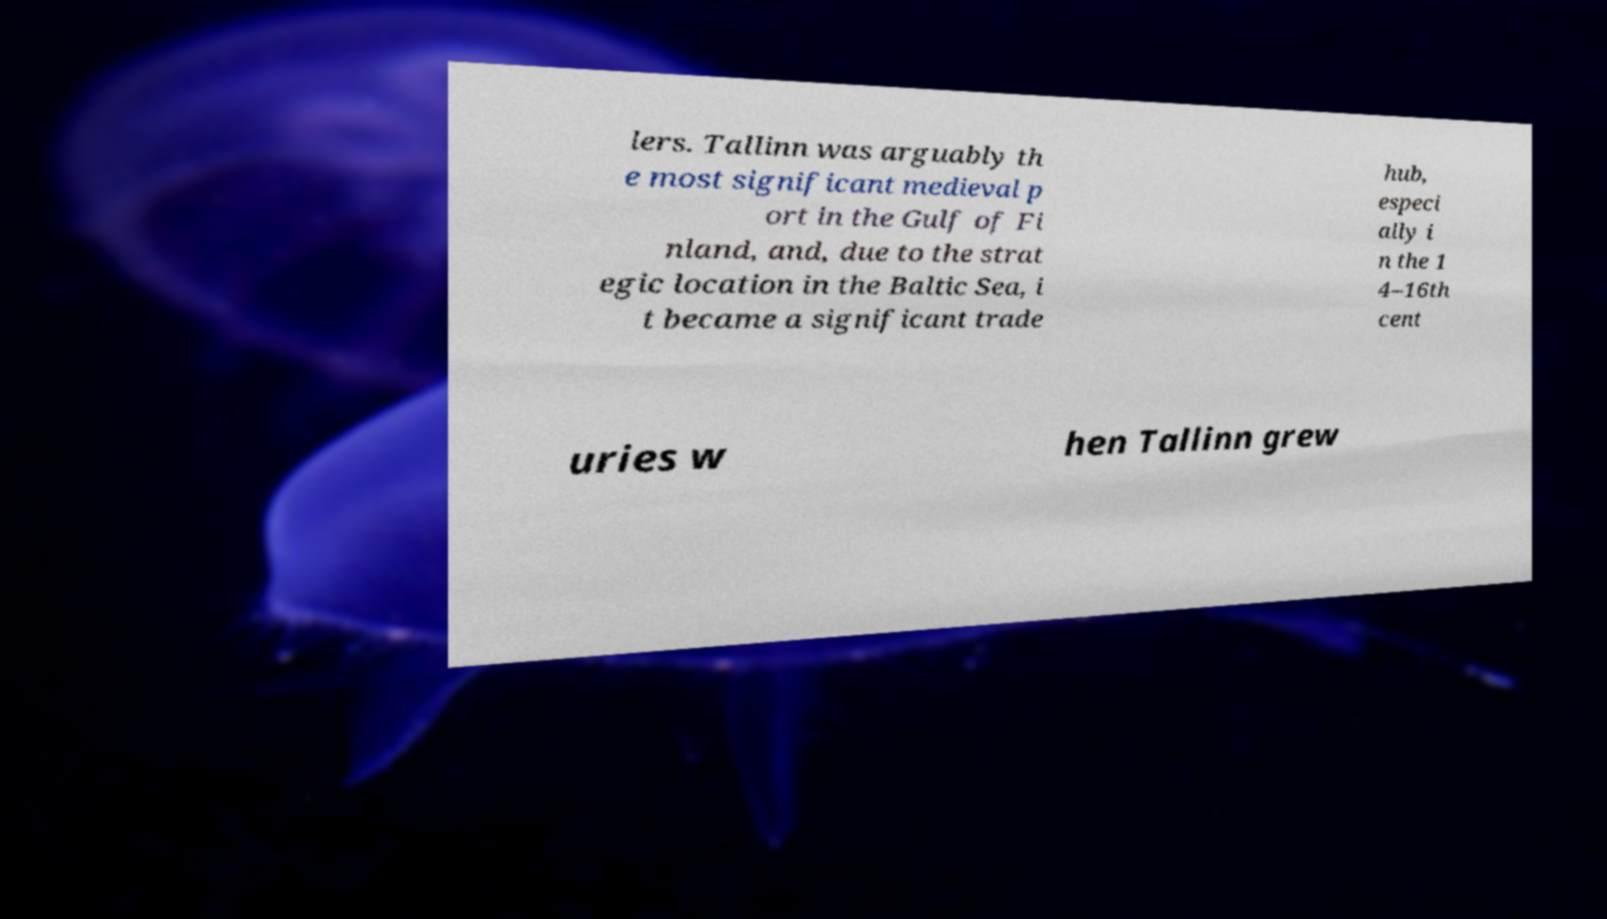Can you accurately transcribe the text from the provided image for me? lers. Tallinn was arguably th e most significant medieval p ort in the Gulf of Fi nland, and, due to the strat egic location in the Baltic Sea, i t became a significant trade hub, especi ally i n the 1 4–16th cent uries w hen Tallinn grew 